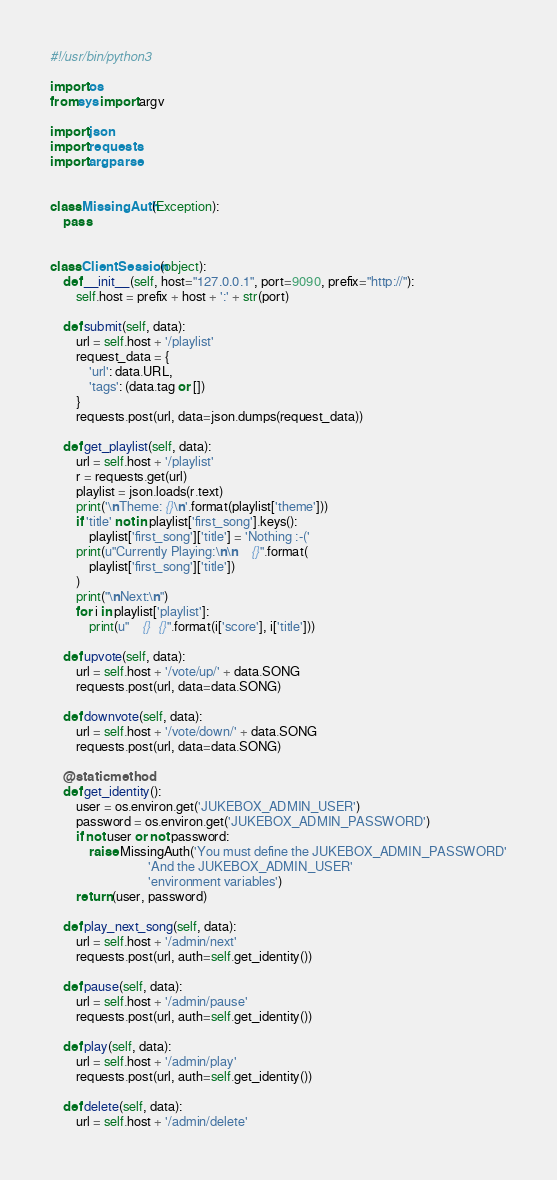<code> <loc_0><loc_0><loc_500><loc_500><_Python_>#!/usr/bin/python3

import os
from sys import argv

import json
import requests
import argparse


class MissingAuth(Exception):
    pass


class ClientSession(object):
    def __init__(self, host="127.0.0.1", port=9090, prefix="http://"):
        self.host = prefix + host + ':' + str(port)

    def submit(self, data):
        url = self.host + '/playlist'
        request_data = {
            'url': data.URL,
            'tags': (data.tag or [])
        }
        requests.post(url, data=json.dumps(request_data))

    def get_playlist(self, data):
        url = self.host + '/playlist'
        r = requests.get(url)
        playlist = json.loads(r.text)
        print('\nTheme: {}\n'.format(playlist['theme']))
        if 'title' not in playlist['first_song'].keys():
            playlist['first_song']['title'] = 'Nothing :-('
        print(u"Currently Playing:\n\n    {}".format(
            playlist['first_song']['title'])
        )
        print("\nNext:\n")
        for i in playlist['playlist']:
            print(u"    {}  {}".format(i['score'], i['title']))

    def upvote(self, data):
        url = self.host + '/vote/up/' + data.SONG
        requests.post(url, data=data.SONG)

    def downvote(self, data):
        url = self.host + '/vote/down/' + data.SONG
        requests.post(url, data=data.SONG)

    @staticmethod
    def get_identity():
        user = os.environ.get('JUKEBOX_ADMIN_USER')
        password = os.environ.get('JUKEBOX_ADMIN_PASSWORD')
        if not user or not password:
            raise MissingAuth('You must define the JUKEBOX_ADMIN_PASSWORD'
                              'And the JUKEBOX_ADMIN_USER'
                              'environment variables')
        return (user, password)

    def play_next_song(self, data):
        url = self.host + '/admin/next'
        requests.post(url, auth=self.get_identity())

    def pause(self, data):
        url = self.host + '/admin/pause'
        requests.post(url, auth=self.get_identity())

    def play(self, data):
        url = self.host + '/admin/play'
        requests.post(url, auth=self.get_identity())

    def delete(self, data):
        url = self.host + '/admin/delete'</code> 